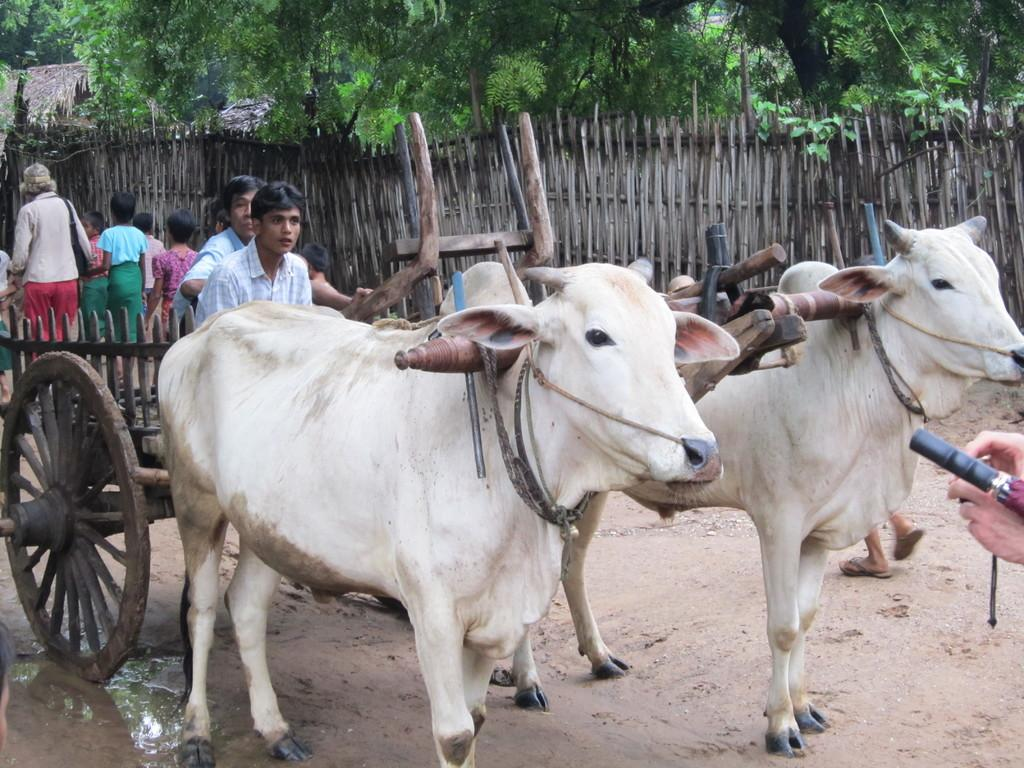What type of vehicle is on the ground in the image? There is a bullock cart on the ground in the image. Can you describe the people in the image? There are people in the image, but their specific actions or appearances are not mentioned in the provided facts. What can be seen in the background of the image? There is a fence, trees, and huts in the background of the image. What type of mine is visible in the image? There is no mine present in the image. Can you describe the scarecrow in the image? There is no scarecrow present in the image. 